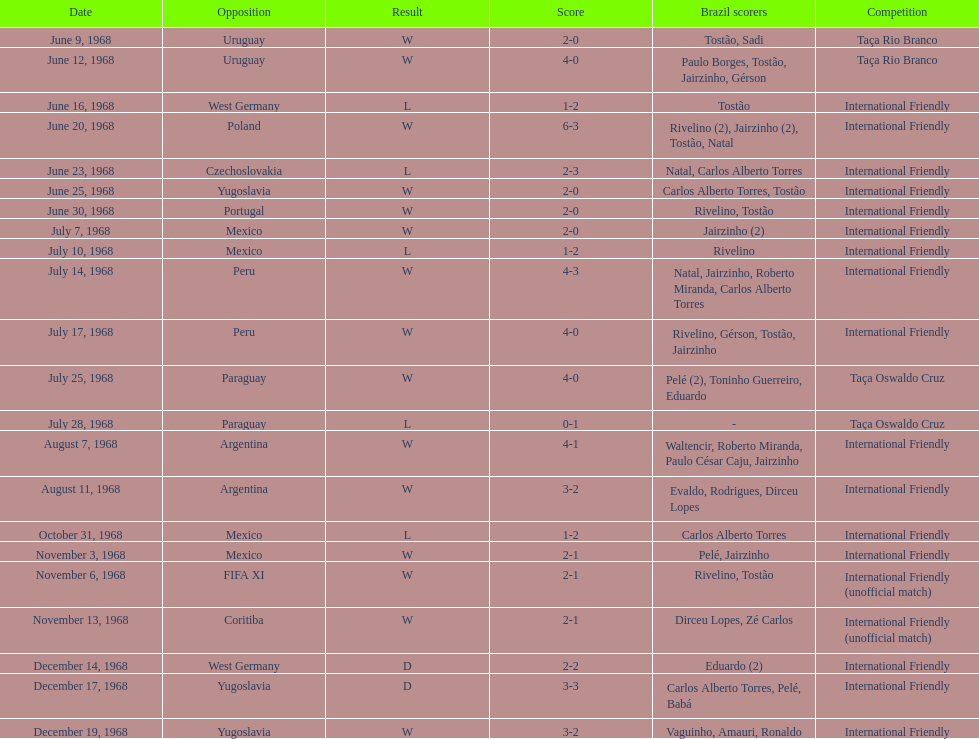How many ties are there in total? 2. 